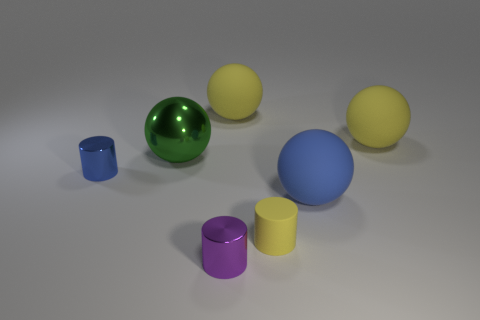There is a shiny thing in front of the yellow cylinder; what color is it?
Your answer should be compact. Purple. There is a metal thing that is in front of the green thing and behind the big blue rubber object; what shape is it?
Make the answer very short. Cylinder. How many other big metallic objects are the same shape as the purple metallic thing?
Your answer should be compact. 0. How many big yellow objects are there?
Offer a very short reply. 2. There is a shiny object that is both in front of the large green object and left of the tiny purple cylinder; what is its size?
Make the answer very short. Small. The green thing that is the same size as the blue rubber thing is what shape?
Offer a very short reply. Sphere. Is there a yellow thing right of the shiny cylinder that is to the right of the tiny blue shiny object?
Give a very brief answer. Yes. The other small rubber thing that is the same shape as the tiny blue thing is what color?
Give a very brief answer. Yellow. There is a matte sphere to the left of the large blue matte sphere; does it have the same color as the small rubber thing?
Your answer should be compact. Yes. What number of objects are blue rubber objects in front of the large metal ball or tiny rubber balls?
Your answer should be compact. 1. 